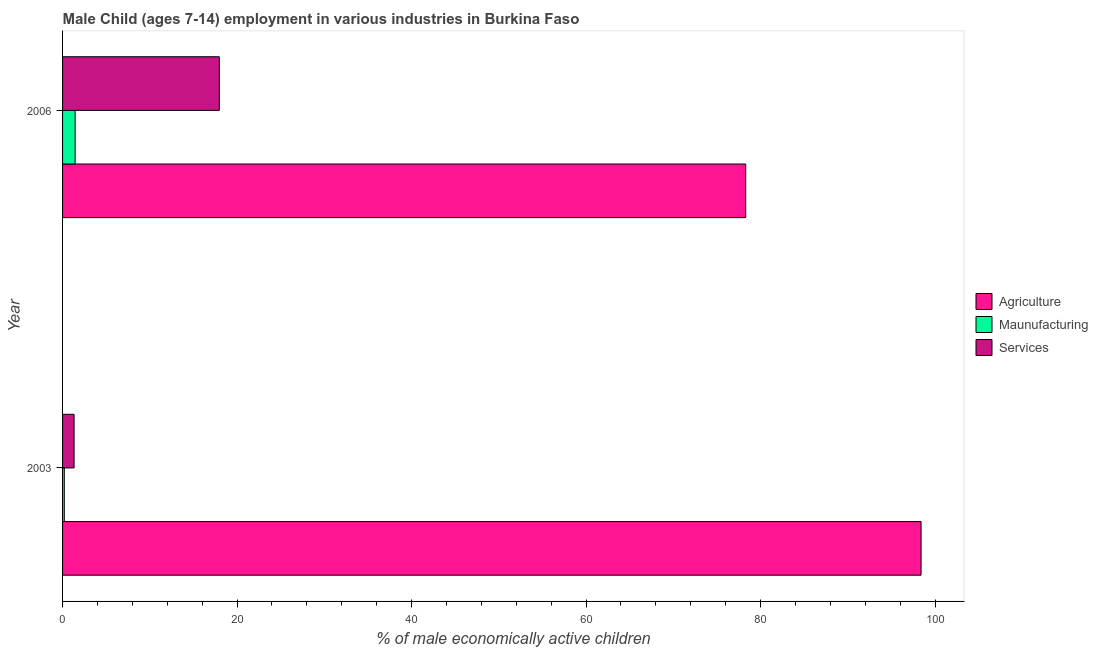How many groups of bars are there?
Provide a succinct answer. 2. How many bars are there on the 1st tick from the top?
Make the answer very short. 3. How many bars are there on the 1st tick from the bottom?
Provide a succinct answer. 3. What is the label of the 2nd group of bars from the top?
Offer a terse response. 2003. What is the percentage of economically active children in services in 2006?
Offer a very short reply. 17.97. Across all years, what is the maximum percentage of economically active children in services?
Offer a very short reply. 17.97. Across all years, what is the minimum percentage of economically active children in agriculture?
Give a very brief answer. 78.3. In which year was the percentage of economically active children in manufacturing maximum?
Your answer should be compact. 2006. What is the total percentage of economically active children in agriculture in the graph?
Keep it short and to the point. 176.7. What is the difference between the percentage of economically active children in manufacturing in 2003 and that in 2006?
Keep it short and to the point. -1.24. What is the difference between the percentage of economically active children in services in 2006 and the percentage of economically active children in manufacturing in 2003?
Provide a succinct answer. 17.77. What is the average percentage of economically active children in agriculture per year?
Ensure brevity in your answer.  88.35. In the year 2003, what is the difference between the percentage of economically active children in agriculture and percentage of economically active children in manufacturing?
Your answer should be very brief. 98.2. In how many years, is the percentage of economically active children in agriculture greater than 88 %?
Your answer should be very brief. 1. What is the ratio of the percentage of economically active children in manufacturing in 2003 to that in 2006?
Your answer should be very brief. 0.14. In how many years, is the percentage of economically active children in manufacturing greater than the average percentage of economically active children in manufacturing taken over all years?
Provide a short and direct response. 1. What does the 3rd bar from the top in 2003 represents?
Ensure brevity in your answer.  Agriculture. What does the 3rd bar from the bottom in 2003 represents?
Your response must be concise. Services. Are all the bars in the graph horizontal?
Your answer should be compact. Yes. How many years are there in the graph?
Provide a succinct answer. 2. Does the graph contain grids?
Keep it short and to the point. No. Where does the legend appear in the graph?
Offer a very short reply. Center right. How are the legend labels stacked?
Provide a succinct answer. Vertical. What is the title of the graph?
Your response must be concise. Male Child (ages 7-14) employment in various industries in Burkina Faso. What is the label or title of the X-axis?
Your answer should be very brief. % of male economically active children. What is the % of male economically active children of Agriculture in 2003?
Offer a terse response. 98.4. What is the % of male economically active children of Services in 2003?
Your answer should be very brief. 1.32. What is the % of male economically active children in Agriculture in 2006?
Keep it short and to the point. 78.3. What is the % of male economically active children in Maunufacturing in 2006?
Give a very brief answer. 1.44. What is the % of male economically active children in Services in 2006?
Provide a succinct answer. 17.97. Across all years, what is the maximum % of male economically active children in Agriculture?
Offer a very short reply. 98.4. Across all years, what is the maximum % of male economically active children of Maunufacturing?
Your response must be concise. 1.44. Across all years, what is the maximum % of male economically active children of Services?
Ensure brevity in your answer.  17.97. Across all years, what is the minimum % of male economically active children of Agriculture?
Offer a terse response. 78.3. Across all years, what is the minimum % of male economically active children in Services?
Give a very brief answer. 1.32. What is the total % of male economically active children of Agriculture in the graph?
Provide a succinct answer. 176.7. What is the total % of male economically active children in Maunufacturing in the graph?
Your answer should be compact. 1.64. What is the total % of male economically active children in Services in the graph?
Your response must be concise. 19.29. What is the difference between the % of male economically active children of Agriculture in 2003 and that in 2006?
Give a very brief answer. 20.1. What is the difference between the % of male economically active children in Maunufacturing in 2003 and that in 2006?
Give a very brief answer. -1.24. What is the difference between the % of male economically active children of Services in 2003 and that in 2006?
Give a very brief answer. -16.65. What is the difference between the % of male economically active children of Agriculture in 2003 and the % of male economically active children of Maunufacturing in 2006?
Provide a succinct answer. 96.96. What is the difference between the % of male economically active children in Agriculture in 2003 and the % of male economically active children in Services in 2006?
Keep it short and to the point. 80.43. What is the difference between the % of male economically active children of Maunufacturing in 2003 and the % of male economically active children of Services in 2006?
Ensure brevity in your answer.  -17.77. What is the average % of male economically active children of Agriculture per year?
Give a very brief answer. 88.35. What is the average % of male economically active children in Maunufacturing per year?
Your answer should be compact. 0.82. What is the average % of male economically active children in Services per year?
Keep it short and to the point. 9.65. In the year 2003, what is the difference between the % of male economically active children in Agriculture and % of male economically active children in Maunufacturing?
Provide a short and direct response. 98.2. In the year 2003, what is the difference between the % of male economically active children of Agriculture and % of male economically active children of Services?
Provide a short and direct response. 97.08. In the year 2003, what is the difference between the % of male economically active children of Maunufacturing and % of male economically active children of Services?
Your answer should be very brief. -1.12. In the year 2006, what is the difference between the % of male economically active children of Agriculture and % of male economically active children of Maunufacturing?
Offer a very short reply. 76.86. In the year 2006, what is the difference between the % of male economically active children in Agriculture and % of male economically active children in Services?
Provide a short and direct response. 60.33. In the year 2006, what is the difference between the % of male economically active children in Maunufacturing and % of male economically active children in Services?
Your response must be concise. -16.53. What is the ratio of the % of male economically active children in Agriculture in 2003 to that in 2006?
Ensure brevity in your answer.  1.26. What is the ratio of the % of male economically active children of Maunufacturing in 2003 to that in 2006?
Your answer should be very brief. 0.14. What is the ratio of the % of male economically active children of Services in 2003 to that in 2006?
Keep it short and to the point. 0.07. What is the difference between the highest and the second highest % of male economically active children of Agriculture?
Make the answer very short. 20.1. What is the difference between the highest and the second highest % of male economically active children of Maunufacturing?
Your answer should be very brief. 1.24. What is the difference between the highest and the second highest % of male economically active children in Services?
Provide a succinct answer. 16.65. What is the difference between the highest and the lowest % of male economically active children in Agriculture?
Make the answer very short. 20.1. What is the difference between the highest and the lowest % of male economically active children in Maunufacturing?
Your response must be concise. 1.24. What is the difference between the highest and the lowest % of male economically active children in Services?
Offer a terse response. 16.65. 